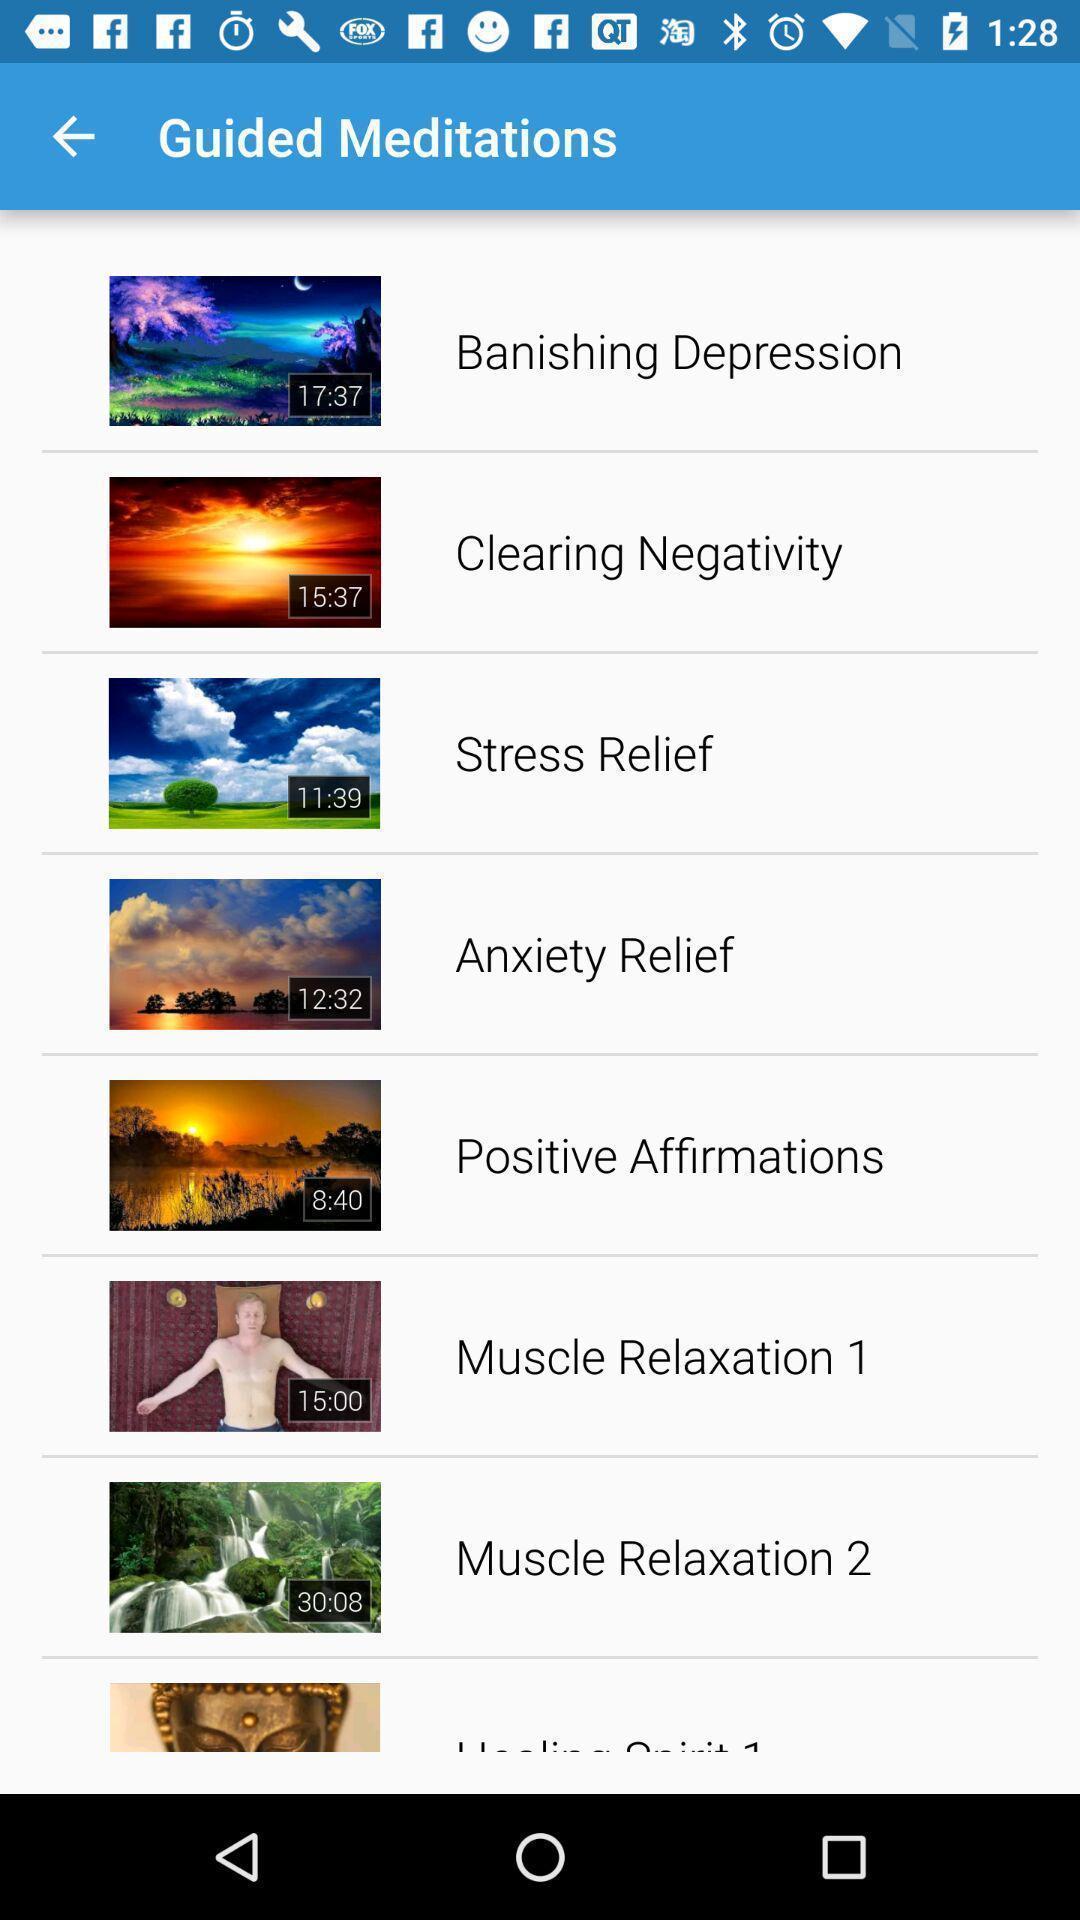What can you discern from this picture? Screen shows multiple options in meditation application. 